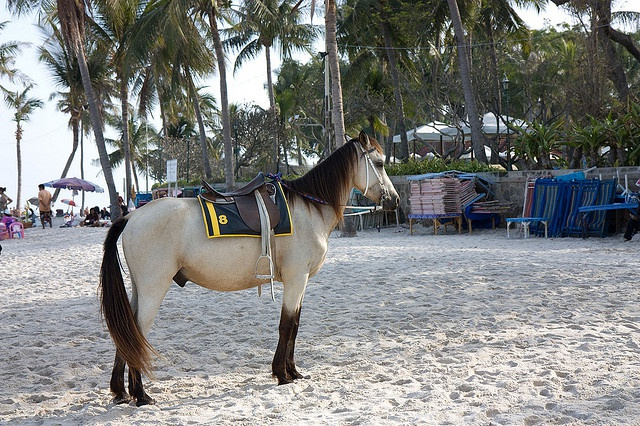Describe the objects in this image and their specific colors. I can see horse in white, darkgray, black, and gray tones, umbrella in white, gray, and darkgray tones, people in white, black, gray, and darkgray tones, people in white, black, and gray tones, and people in white, gray, black, and darkgray tones in this image. 